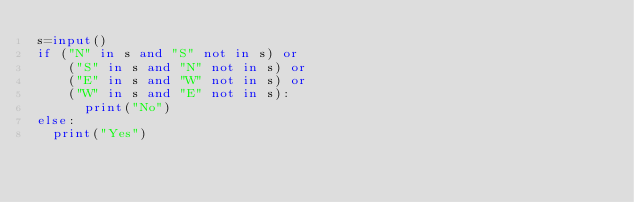<code> <loc_0><loc_0><loc_500><loc_500><_Python_>s=input()
if ("N" in s and "S" not in s) or
	("S" in s and "N" not in s) or
	("E" in s and "W" not in s) or
    ("W" in s and "E" not in s):
      print("No")
else:
  print("Yes")</code> 